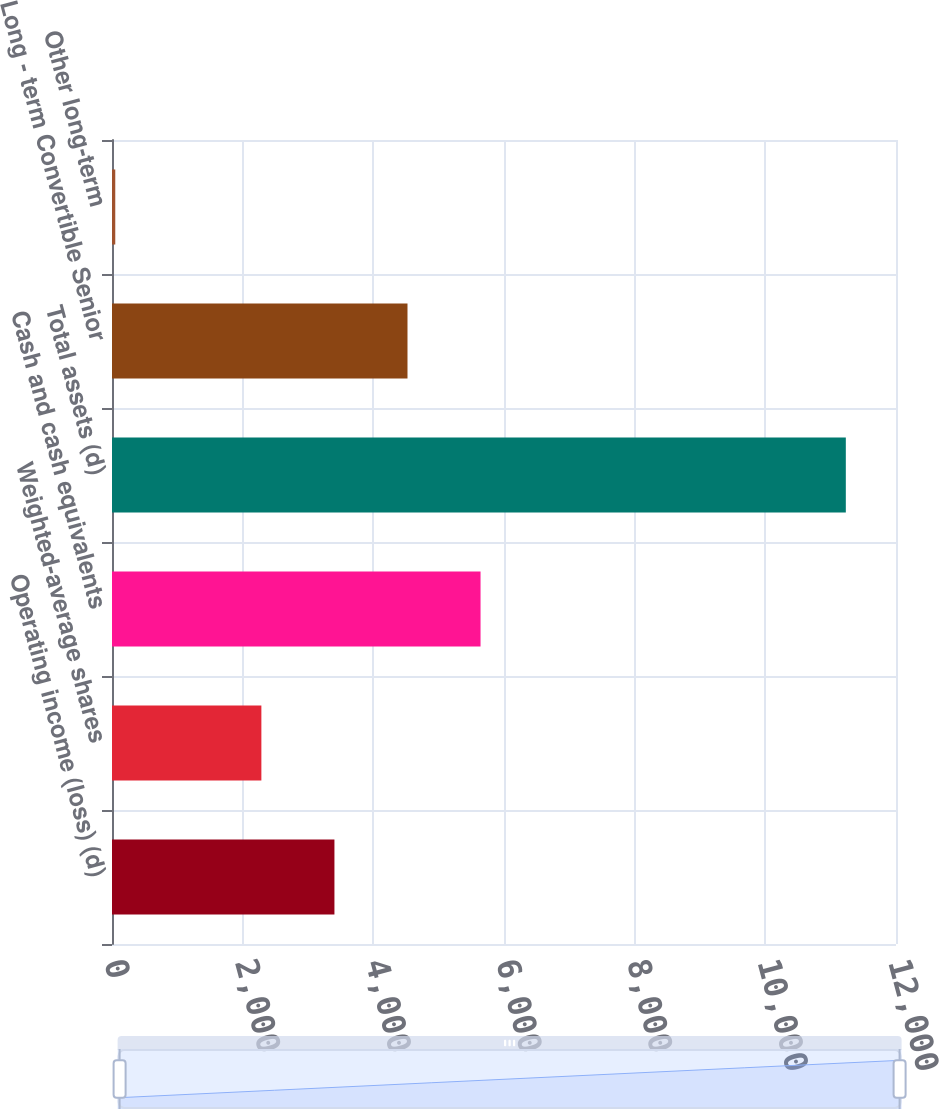Convert chart to OTSL. <chart><loc_0><loc_0><loc_500><loc_500><bar_chart><fcel>Operating income (loss) (d)<fcel>Weighted-average shares<fcel>Cash and cash equivalents<fcel>Total assets (d)<fcel>Long - term Convertible Senior<fcel>Other long-term<nl><fcel>3404.6<fcel>2286.4<fcel>5641<fcel>11232<fcel>4522.8<fcel>50<nl></chart> 